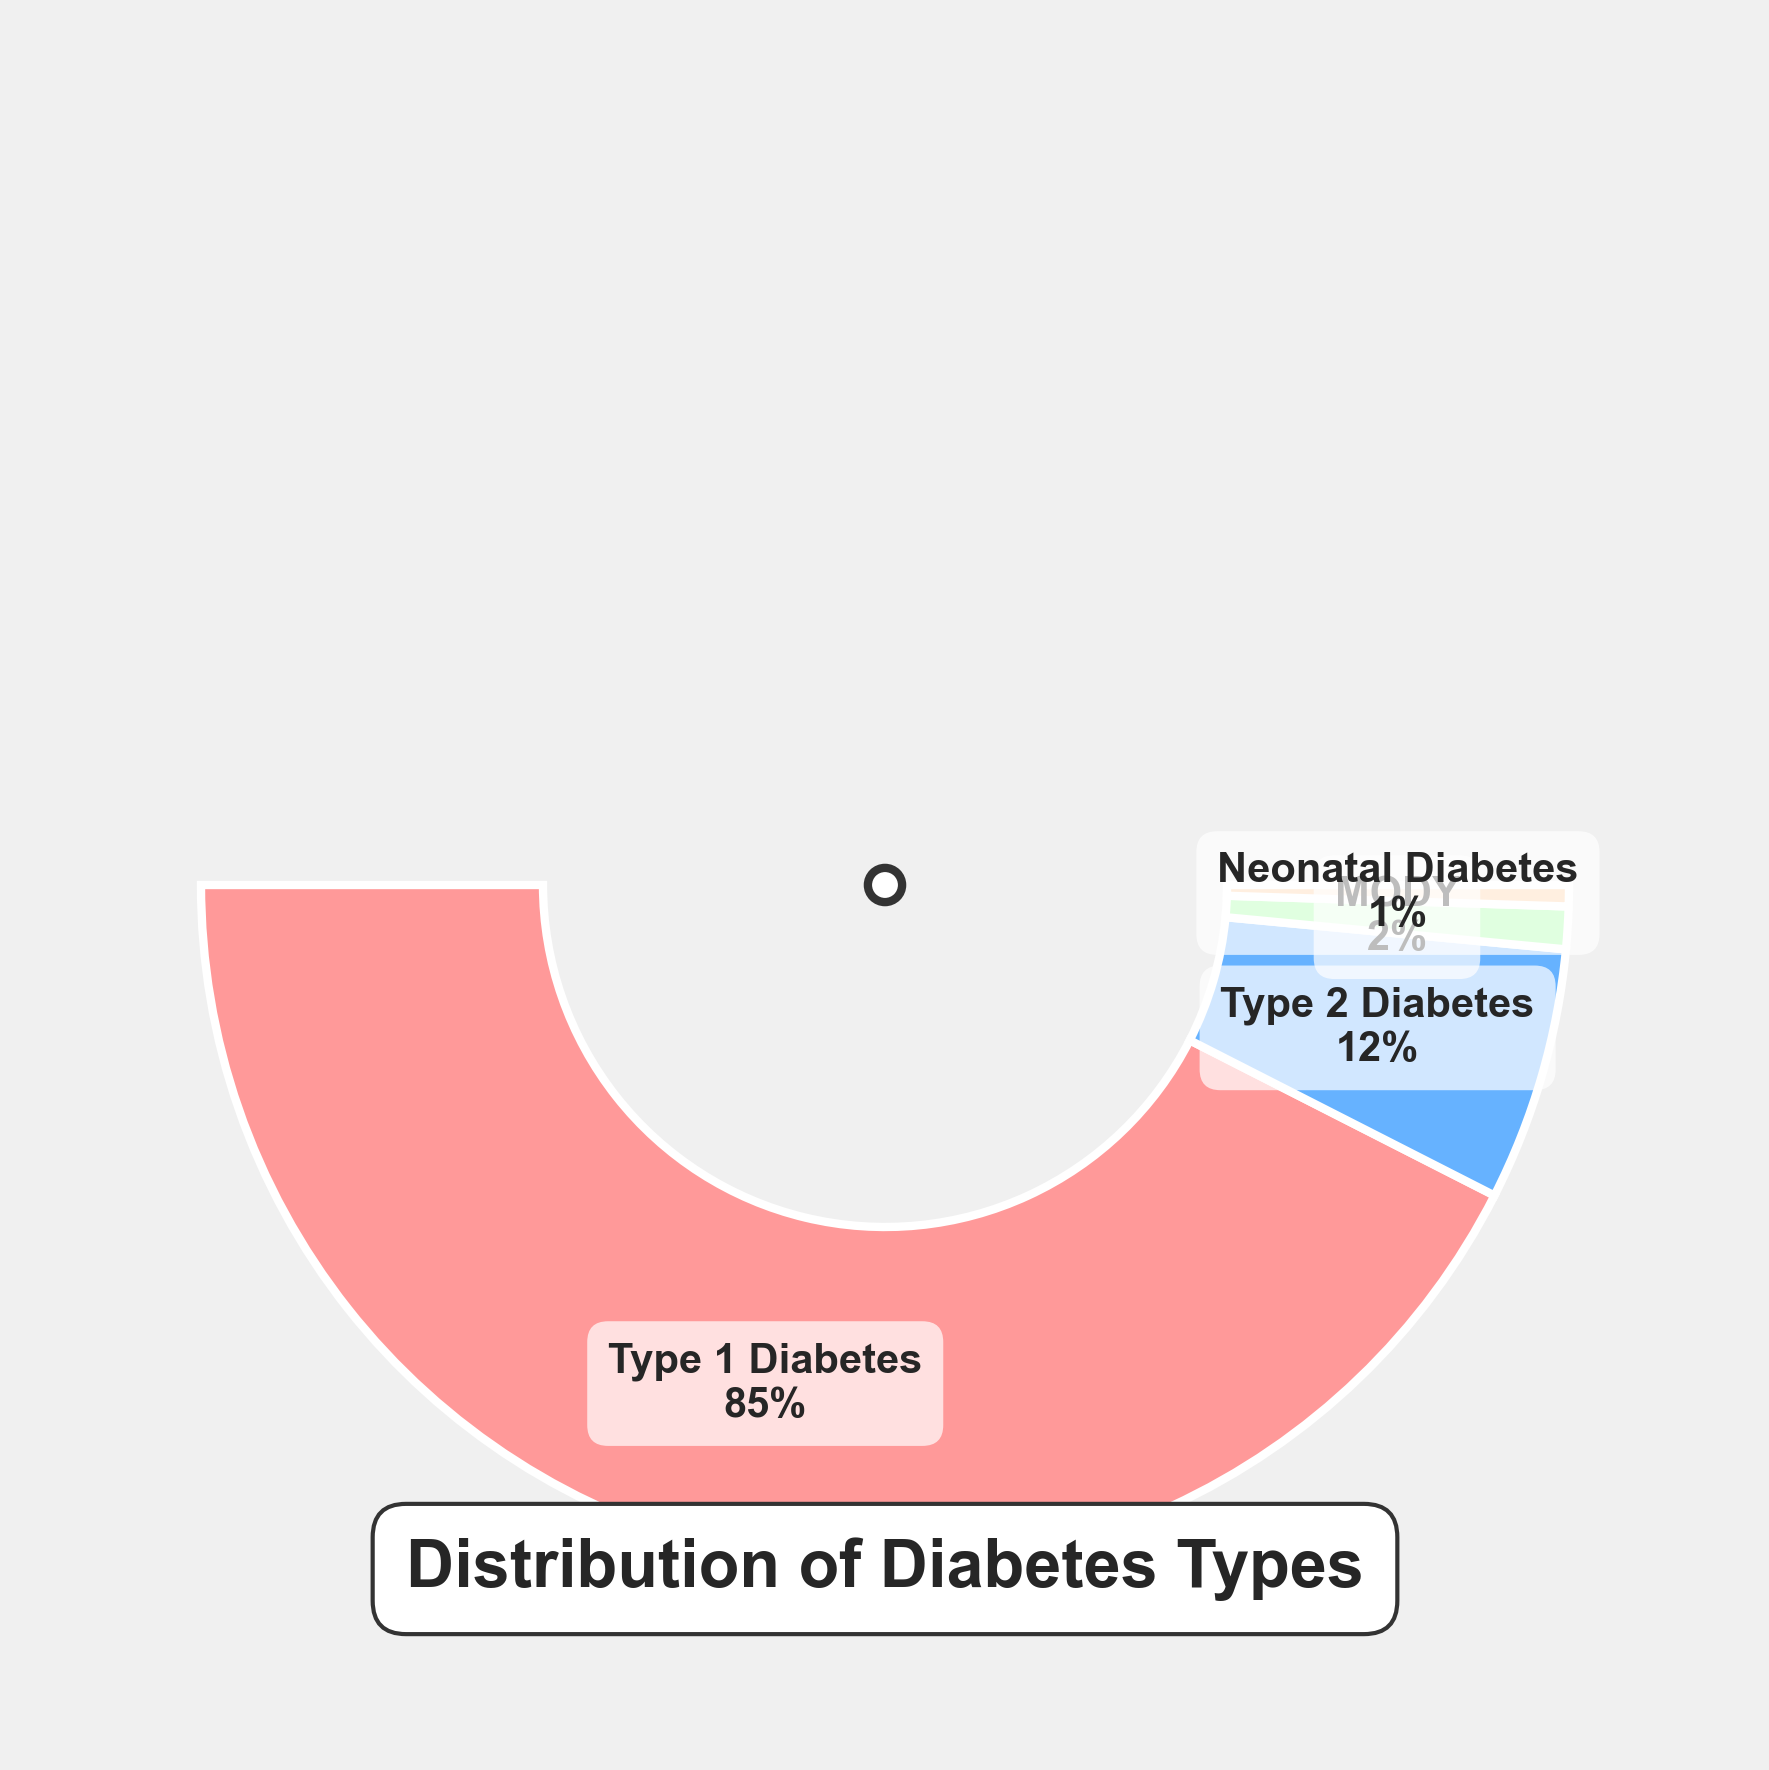What types of diabetes are represented in the figure? The figure uses text labels to represent the different types of diabetes, which include Type 1 Diabetes, Type 2 Diabetes, MODY, and Neonatal Diabetes.
Answer: Type 1 Diabetes, Type 2 Diabetes, MODY, Neonatal Diabetes What is the title of the figure? The title of the figure is placed near the bottom with large, bold text surrounded by a rounded box.
Answer: Distribution of Diabetes Types Which type of diabetes has the highest percentage among school-aged children? Observing the wedges and the provided text within them, Type 1 Diabetes has the largest wedge and also the highest percentage text label.
Answer: Type 1 Diabetes What's the total percentage for Type 2 Diabetes and MODY combined? Summing the percentages from the labels for Type 2 Diabetes (12%) and MODY (2%), the total is 12% + 2% = 14%.
Answer: 14% Which type of diabetes has the smallest percentage? Among the wedges, the smallest one, which is accompanied by the text label showing the percentage, is for Neonatal Diabetes.
Answer: Neonatal Diabetes How much larger is the percentage of Type 1 Diabetes compared to Type 2 Diabetes? Subtracting the percentage of Type 2 Diabetes (12%) from the percentage of Type 1 Diabetes (85%), the difference is 85% - 12% = 73%.
Answer: 73% How are the data points visually represented in the plotting area? The data points are visually represented with wedges in a semicircular gauge chart. Each wedge represents a type of diabetes and shows its corresponding percentage within the chart.
Answer: Wedges Which types of diabetes combined have a percentage less than MODY? Only Neonatal Diabetes, which has a percentage (1%) less than MODY (2%).
Answer: Neonatal Diabetes How does the figure highlight the title? The title is centered at the bottom of the gauge chart, with a bold font and encompassed by a rounded box, making it prominent.
Answer: Bold text in rounded box What color scheme is used to differentiate the diabetes types? The wedges have different pastel colors: pink for Type 1 Diabetes, blue for Type 2 Diabetes, green for MODY, and orange for Neonatal Diabetes.
Answer: Pink, blue, green, orange 